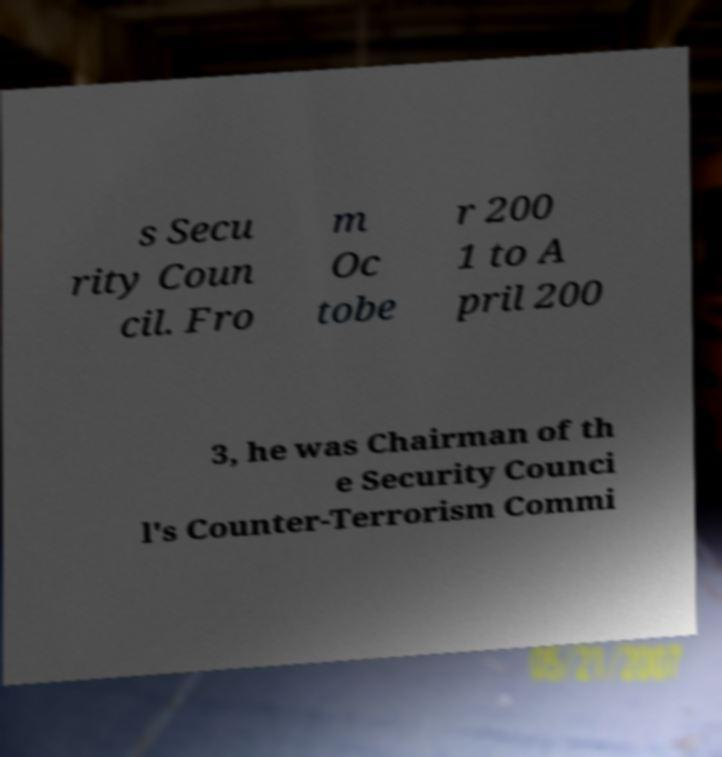There's text embedded in this image that I need extracted. Can you transcribe it verbatim? s Secu rity Coun cil. Fro m Oc tobe r 200 1 to A pril 200 3, he was Chairman of th e Security Counci l's Counter-Terrorism Commi 